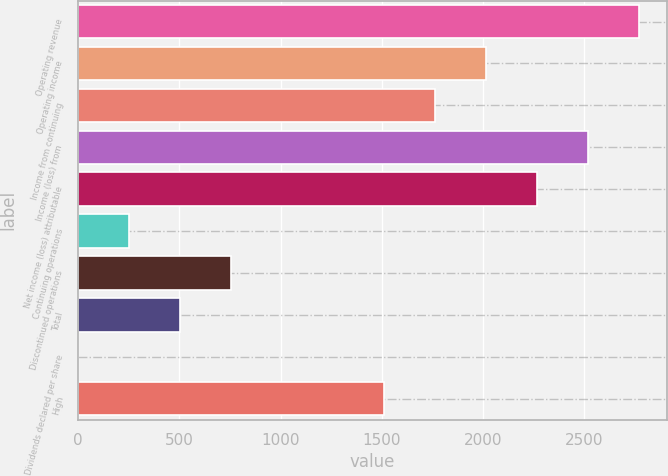Convert chart. <chart><loc_0><loc_0><loc_500><loc_500><bar_chart><fcel>Operating revenue<fcel>Operating income<fcel>Income from continuing<fcel>Income (loss) from<fcel>Net income (loss) attributable<fcel>Continuing operations<fcel>Discontinued operations<fcel>Total<fcel>Dividends declared per share<fcel>High<nl><fcel>2768.7<fcel>2013.69<fcel>1762.02<fcel>2517.03<fcel>2265.36<fcel>252<fcel>755.34<fcel>503.67<fcel>0.33<fcel>1510.35<nl></chart> 